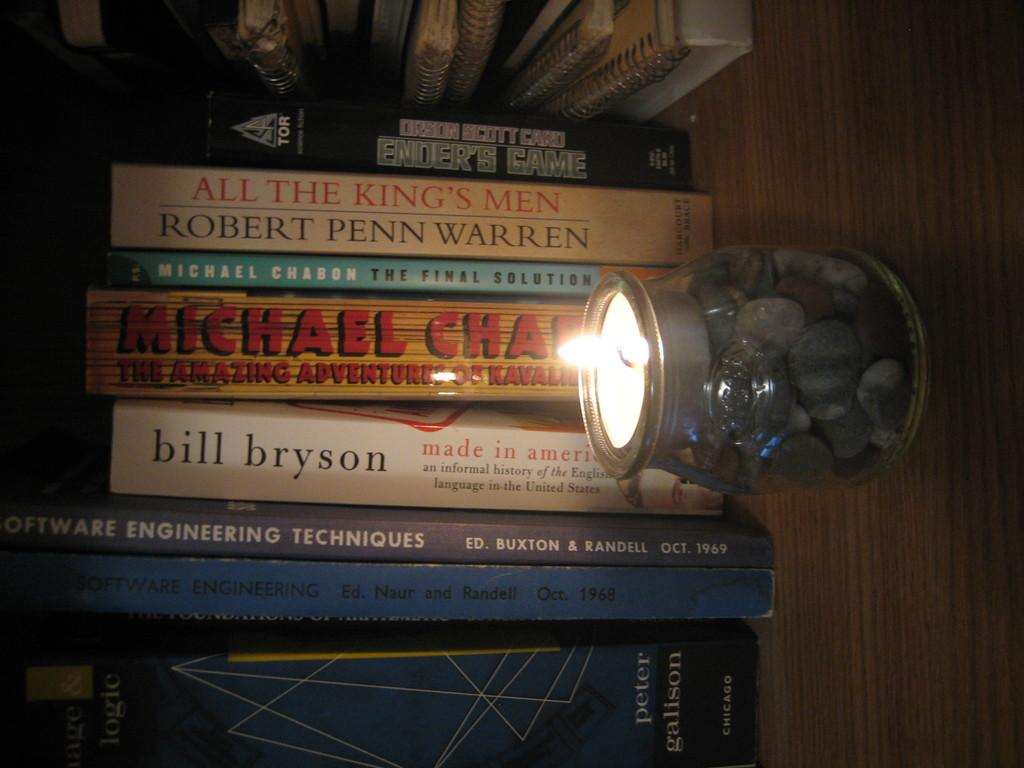Provide a one-sentence caption for the provided image. a stack of books that has one of them by 'bill bryson'. 